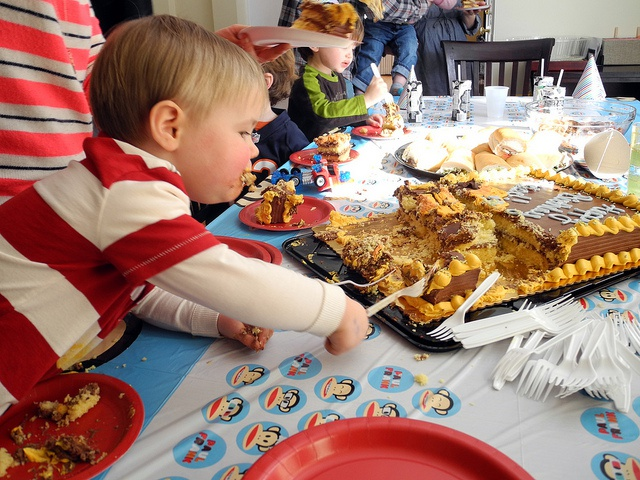Describe the objects in this image and their specific colors. I can see dining table in gray, lightgray, darkgray, maroon, and brown tones, people in gray, maroon, and tan tones, cake in gray, brown, maroon, tan, and orange tones, people in gray, salmon, brown, darkgray, and tan tones, and fork in gray, lightgray, and darkgray tones in this image. 